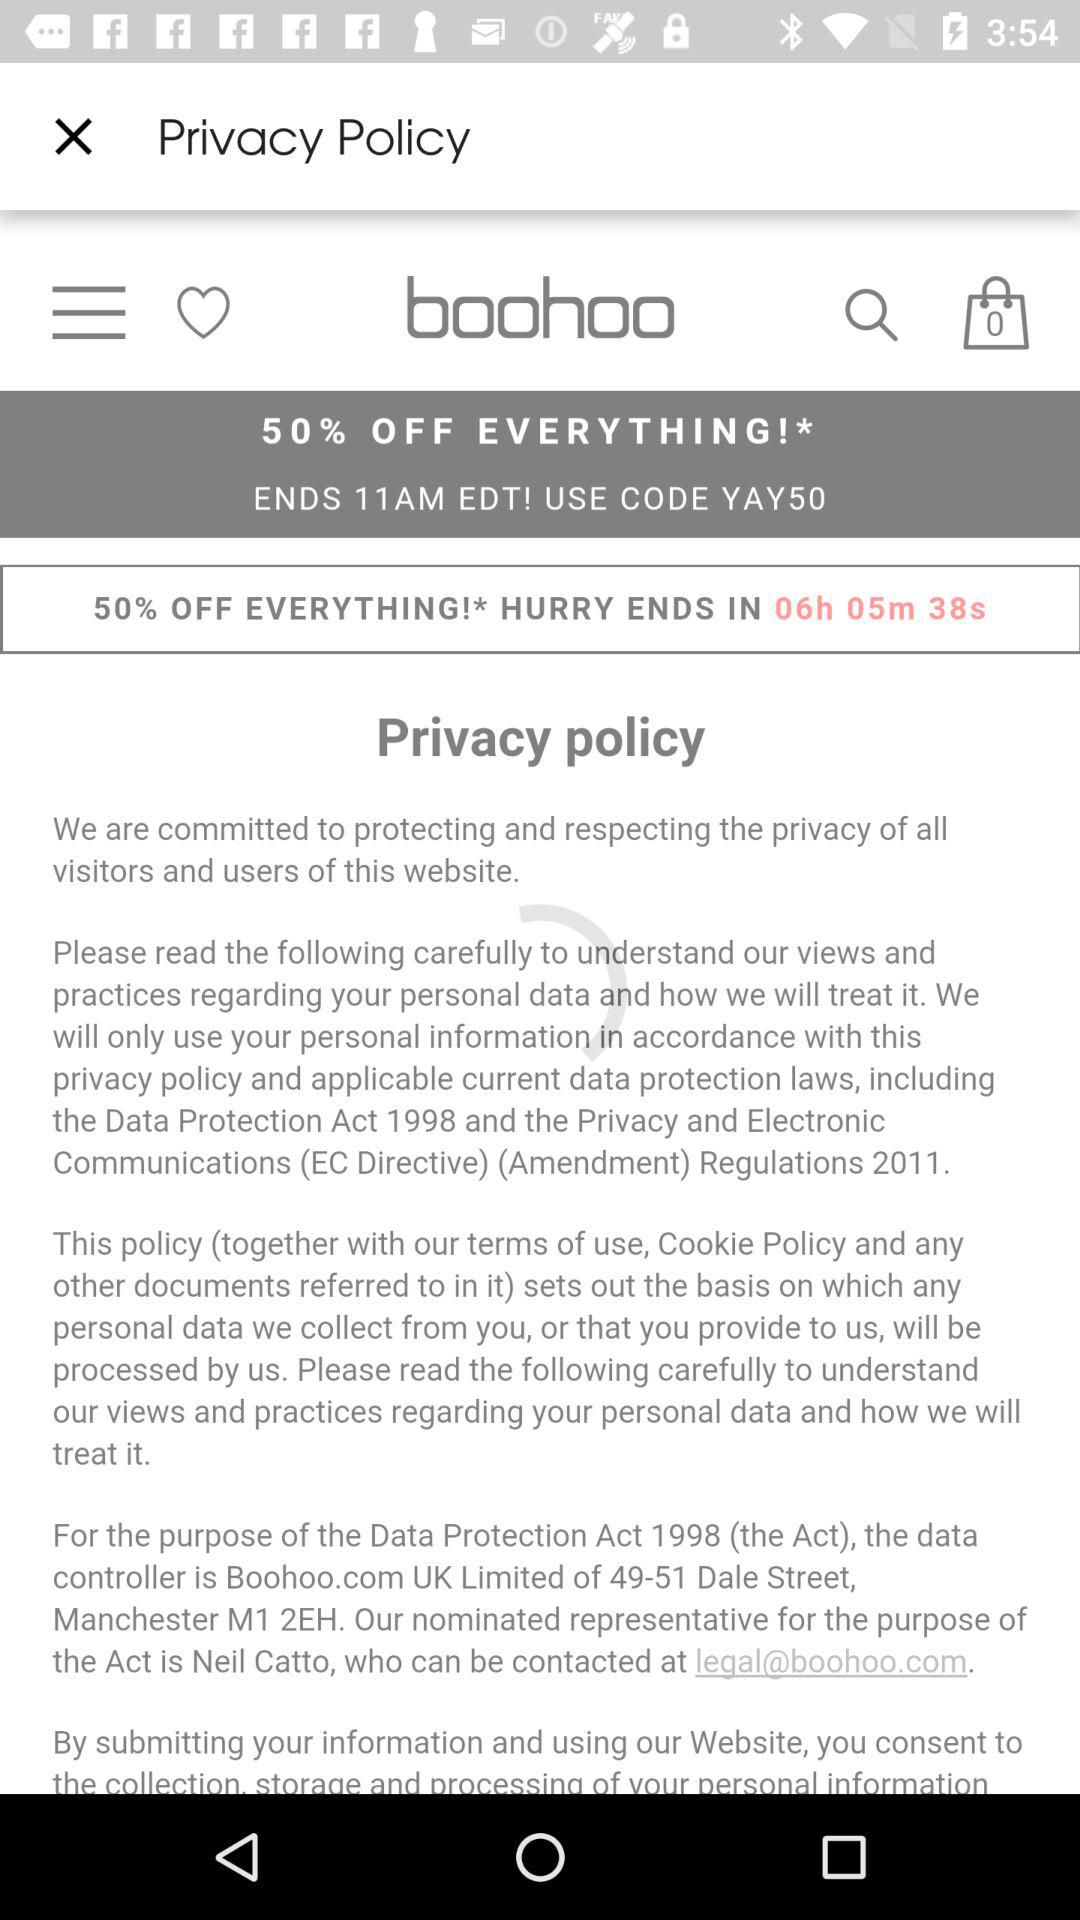When will the sale end? The sale will end at 11 a.m. 